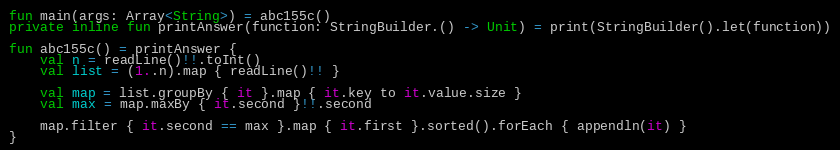Convert code to text. <code><loc_0><loc_0><loc_500><loc_500><_Kotlin_>fun main(args: Array<String>) = abc155c()
private inline fun printAnswer(function: StringBuilder.() -> Unit) = print(StringBuilder().let(function))

fun abc155c() = printAnswer {
    val n = readLine()!!.toInt()
    val list = (1..n).map { readLine()!! }

    val map = list.groupBy { it }.map { it.key to it.value.size }
    val max = map.maxBy { it.second }!!.second

    map.filter { it.second == max }.map { it.first }.sorted().forEach { appendln(it) }
}
</code> 